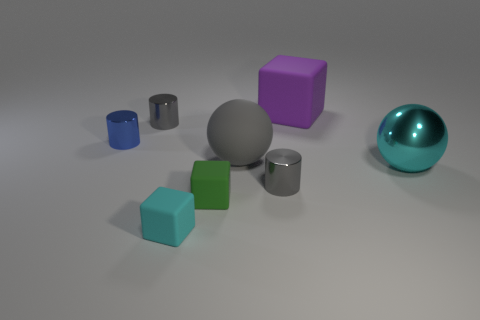What number of other objects are the same size as the cyan cube?
Your response must be concise. 4. Are there the same number of matte things that are behind the gray sphere and big cyan balls?
Provide a short and direct response. Yes. Does the cylinder to the right of the tiny green matte cube have the same color as the large ball left of the purple rubber thing?
Your answer should be very brief. Yes. There is a thing that is to the right of the cyan cube and behind the blue metal cylinder; what material is it?
Your answer should be very brief. Rubber. The rubber ball has what color?
Your answer should be very brief. Gray. What number of other objects are the same shape as the large cyan thing?
Provide a succinct answer. 1. Is the number of cyan spheres that are to the left of the cyan matte thing the same as the number of matte cubes that are right of the tiny green matte object?
Provide a short and direct response. No. What material is the gray sphere?
Your answer should be compact. Rubber. What is the big thing that is to the left of the large purple rubber block made of?
Your response must be concise. Rubber. Are there more small blue metallic cylinders left of the small cyan thing than large cyan matte balls?
Your response must be concise. Yes. 